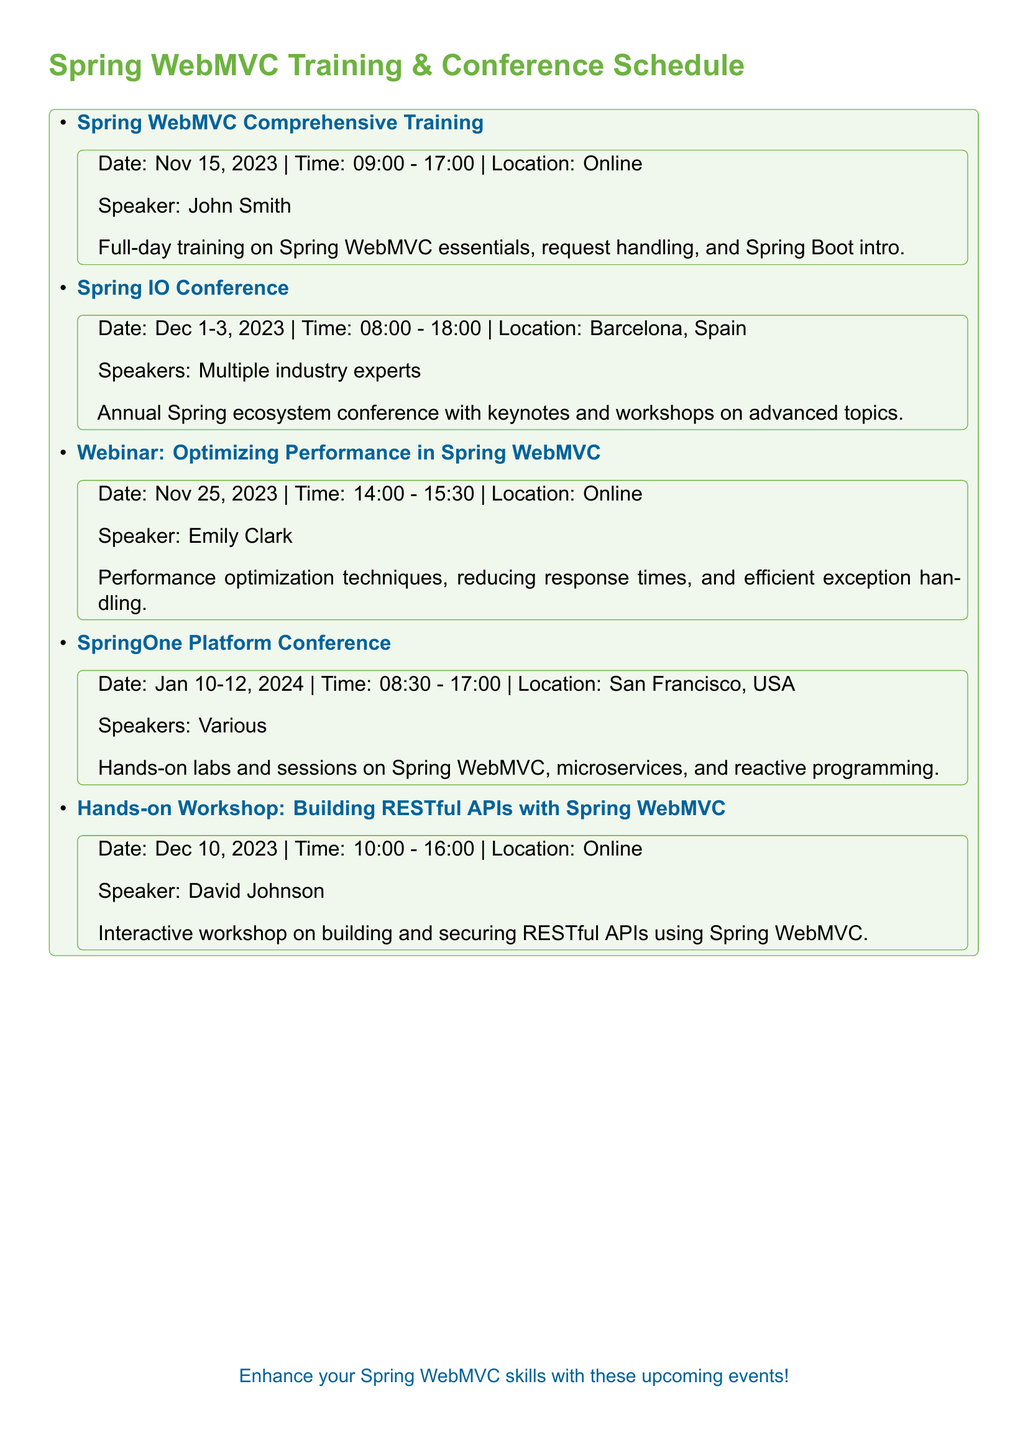What is the date of the Spring WebMVC Comprehensive Training? The document states that the Spring WebMVC Comprehensive Training is scheduled for November 15, 2023.
Answer: November 15, 2023 Who is the speaker for the Webinar on Optimizing Performance in Spring WebMVC? The document lists Emily Clark as the speaker for the Webinar on Optimizing Performance in Spring WebMVC.
Answer: Emily Clark What is the duration of the SpringOne Platform Conference? The SpringOne Platform Conference spans three days from January 10 to January 12, 2024.
Answer: Three days Where is the Spring IO Conference taking place? According to the document, the location of the Spring IO Conference is Barcelona, Spain.
Answer: Barcelona, Spain What type of event is scheduled on December 10, 2023? The document describes it as a Hands-on Workshop: Building RESTful APIs with Spring WebMVC.
Answer: Workshop How many days does the Spring IO Conference last? The conference lasts for three days from December 1 to December 3, 2023.
Answer: Three days What topic does David Johnson focus on in his workshop? David Johnson focuses on Building RESTful APIs with Spring WebMVC in his workshop.
Answer: Building RESTful APIs What is the time of the Webinar on the 25th of November? The document specifies that the time for the Webinar on November 25, 2023, is from 2:00 PM to 3:30 PM.
Answer: 14:00 - 15:30 What is emphasized in the training session on November 15? The document highlights essentials of Spring WebMVC, request handling, and an introduction to Spring Boot.
Answer: Spring WebMVC essentials 